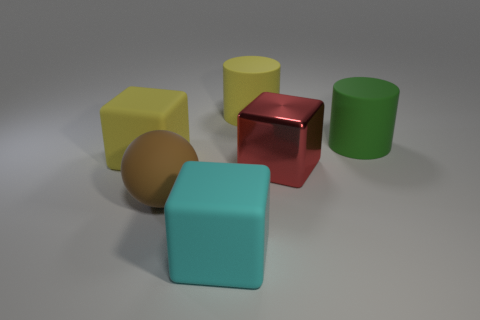What number of things are tiny yellow metallic blocks or blocks that are on the left side of the brown rubber object?
Make the answer very short. 1. Is the number of large cylinders in front of the brown rubber thing the same as the number of big cyan metallic balls?
Your response must be concise. Yes. There is a green thing that is made of the same material as the big brown thing; what is its shape?
Give a very brief answer. Cylinder. Are there any other spheres of the same color as the big sphere?
Make the answer very short. No. How many matte things are either big cyan things or big green cylinders?
Ensure brevity in your answer.  2. What number of large things are behind the large brown rubber object that is in front of the large yellow block?
Offer a terse response. 4. How many cyan cubes have the same material as the large sphere?
Your response must be concise. 1. What number of tiny objects are either rubber balls or yellow rubber cylinders?
Your answer should be compact. 0. The matte object that is right of the large cyan rubber thing and on the left side of the green object has what shape?
Your response must be concise. Cylinder. Does the large cyan block have the same material as the brown object?
Offer a very short reply. Yes. 